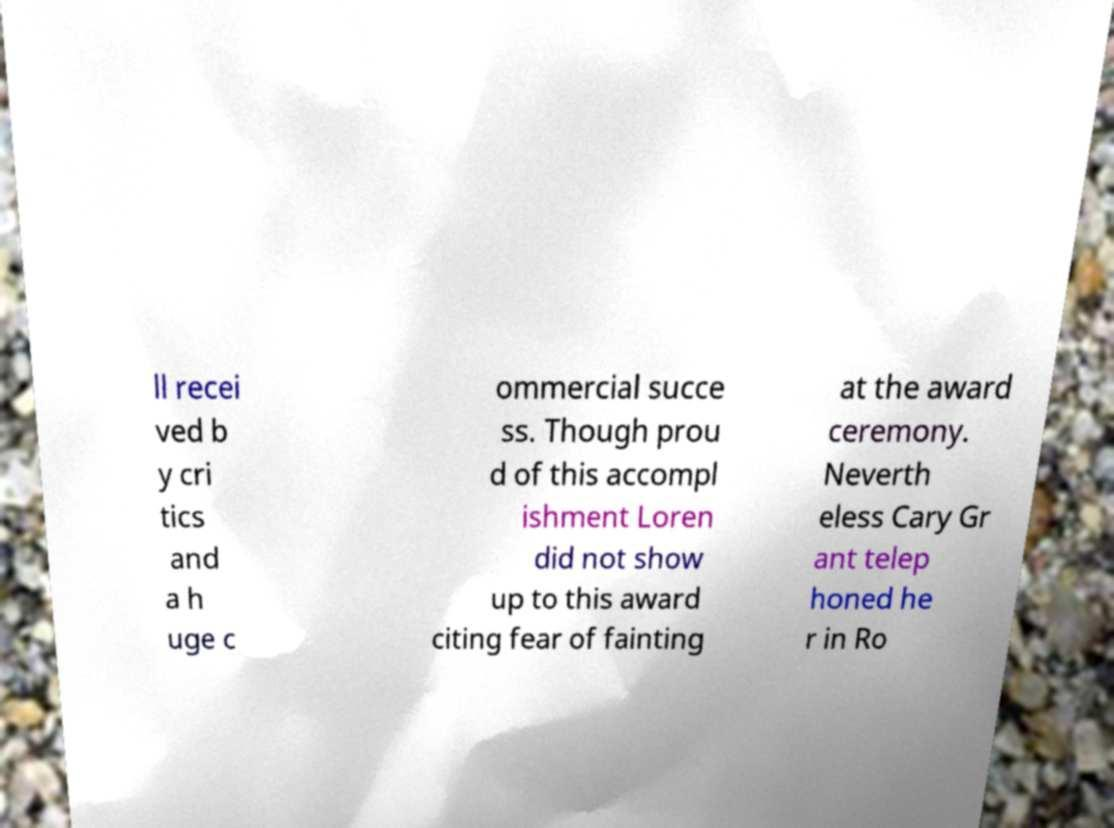There's text embedded in this image that I need extracted. Can you transcribe it verbatim? ll recei ved b y cri tics and a h uge c ommercial succe ss. Though prou d of this accompl ishment Loren did not show up to this award citing fear of fainting at the award ceremony. Neverth eless Cary Gr ant telep honed he r in Ro 